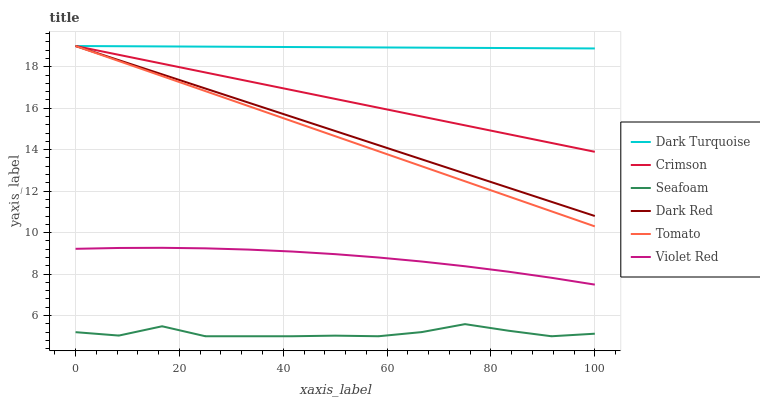Does Seafoam have the minimum area under the curve?
Answer yes or no. Yes. Does Dark Turquoise have the maximum area under the curve?
Answer yes or no. Yes. Does Violet Red have the minimum area under the curve?
Answer yes or no. No. Does Violet Red have the maximum area under the curve?
Answer yes or no. No. Is Crimson the smoothest?
Answer yes or no. Yes. Is Seafoam the roughest?
Answer yes or no. Yes. Is Violet Red the smoothest?
Answer yes or no. No. Is Violet Red the roughest?
Answer yes or no. No. Does Seafoam have the lowest value?
Answer yes or no. Yes. Does Violet Red have the lowest value?
Answer yes or no. No. Does Crimson have the highest value?
Answer yes or no. Yes. Does Violet Red have the highest value?
Answer yes or no. No. Is Seafoam less than Dark Turquoise?
Answer yes or no. Yes. Is Tomato greater than Violet Red?
Answer yes or no. Yes. Does Crimson intersect Tomato?
Answer yes or no. Yes. Is Crimson less than Tomato?
Answer yes or no. No. Is Crimson greater than Tomato?
Answer yes or no. No. Does Seafoam intersect Dark Turquoise?
Answer yes or no. No. 